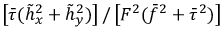<formula> <loc_0><loc_0><loc_500><loc_500>\left [ \bar { \tau } ( \tilde { h } _ { x } ^ { 2 } + \tilde { h } _ { y } ^ { 2 } ) \right ] / \left [ F ^ { 2 } ( \bar { f } ^ { 2 } + \bar { \tau } ^ { 2 } ) \right ]</formula> 